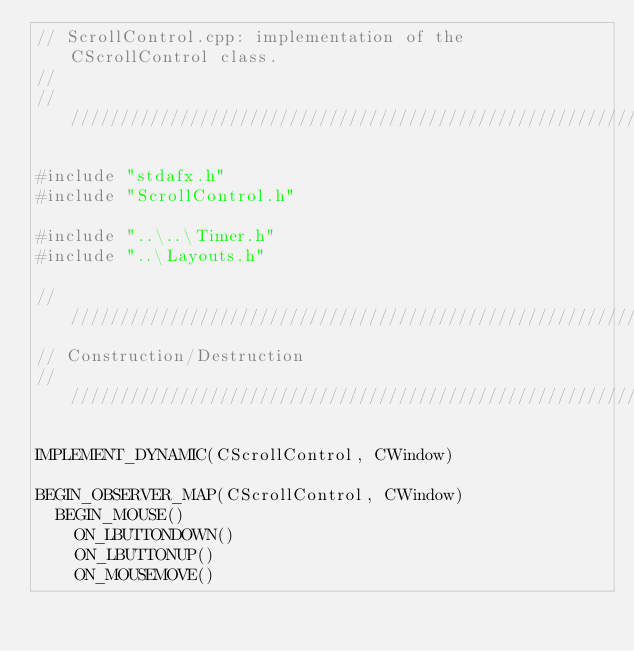Convert code to text. <code><loc_0><loc_0><loc_500><loc_500><_C++_>// ScrollControl.cpp: implementation of the CScrollControl class.
//
//////////////////////////////////////////////////////////////////////

#include "stdafx.h"
#include "ScrollControl.h"

#include "..\..\Timer.h"
#include "..\Layouts.h"

//////////////////////////////////////////////////////////////////////
// Construction/Destruction
//////////////////////////////////////////////////////////////////////

IMPLEMENT_DYNAMIC(CScrollControl, CWindow)

BEGIN_OBSERVER_MAP(CScrollControl, CWindow)
  BEGIN_MOUSE()
    ON_LBUTTONDOWN()
    ON_LBUTTONUP()
    ON_MOUSEMOVE()</code> 